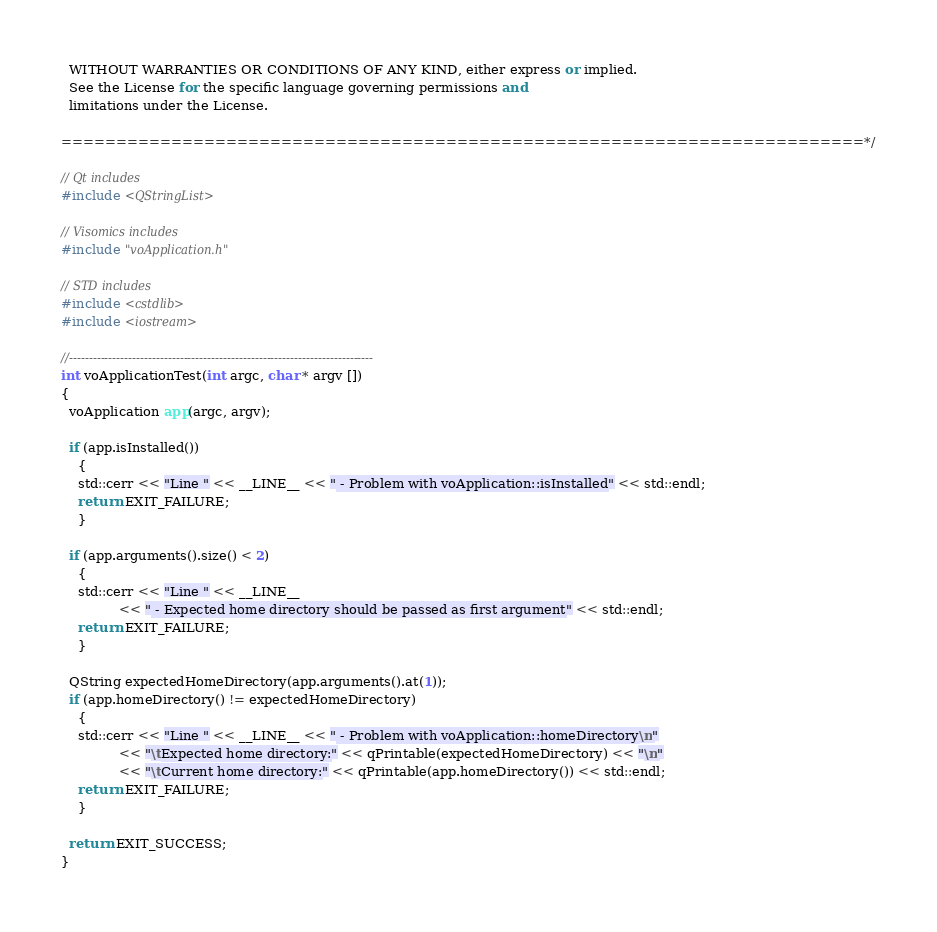Convert code to text. <code><loc_0><loc_0><loc_500><loc_500><_C++_>  WITHOUT WARRANTIES OR CONDITIONS OF ANY KIND, either express or implied.
  See the License for the specific language governing permissions and
  limitations under the License.

=========================================================================*/

// Qt includes
#include <QStringList>

// Visomics includes
#include "voApplication.h"

// STD includes
#include <cstdlib>
#include <iostream>

//-----------------------------------------------------------------------------
int voApplicationTest(int argc, char * argv [])
{
  voApplication app(argc, argv);

  if (app.isInstalled())
    {
    std::cerr << "Line " << __LINE__ << " - Problem with voApplication::isInstalled" << std::endl;
    return EXIT_FAILURE;
    }

  if (app.arguments().size() < 2)
    {
    std::cerr << "Line " << __LINE__
              << " - Expected home directory should be passed as first argument" << std::endl;
    return EXIT_FAILURE;
    }

  QString expectedHomeDirectory(app.arguments().at(1));
  if (app.homeDirectory() != expectedHomeDirectory)
    {
    std::cerr << "Line " << __LINE__ << " - Problem with voApplication::homeDirectory\n"
              << "\tExpected home directory:" << qPrintable(expectedHomeDirectory) << "\n"
              << "\tCurrent home directory:" << qPrintable(app.homeDirectory()) << std::endl;
    return EXIT_FAILURE;
    }

  return EXIT_SUCCESS;
}
</code> 